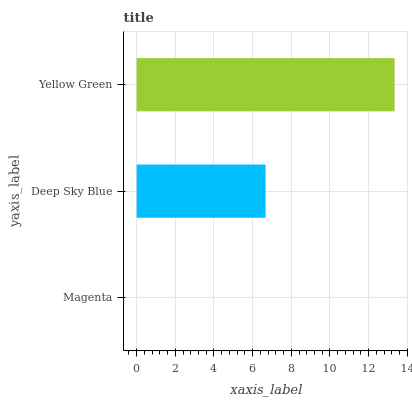Is Magenta the minimum?
Answer yes or no. Yes. Is Yellow Green the maximum?
Answer yes or no. Yes. Is Deep Sky Blue the minimum?
Answer yes or no. No. Is Deep Sky Blue the maximum?
Answer yes or no. No. Is Deep Sky Blue greater than Magenta?
Answer yes or no. Yes. Is Magenta less than Deep Sky Blue?
Answer yes or no. Yes. Is Magenta greater than Deep Sky Blue?
Answer yes or no. No. Is Deep Sky Blue less than Magenta?
Answer yes or no. No. Is Deep Sky Blue the high median?
Answer yes or no. Yes. Is Deep Sky Blue the low median?
Answer yes or no. Yes. Is Magenta the high median?
Answer yes or no. No. Is Magenta the low median?
Answer yes or no. No. 